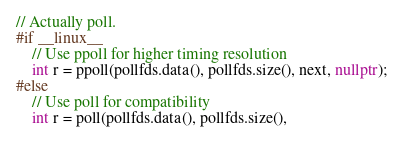Convert code to text. <code><loc_0><loc_0><loc_500><loc_500><_C++_>// Actually poll.
#if __linux__
    // Use ppoll for higher timing resolution
    int r = ppoll(pollfds.data(), pollfds.size(), next, nullptr);
#else
    // Use poll for compatibility
    int r = poll(pollfds.data(), pollfds.size(),</code> 